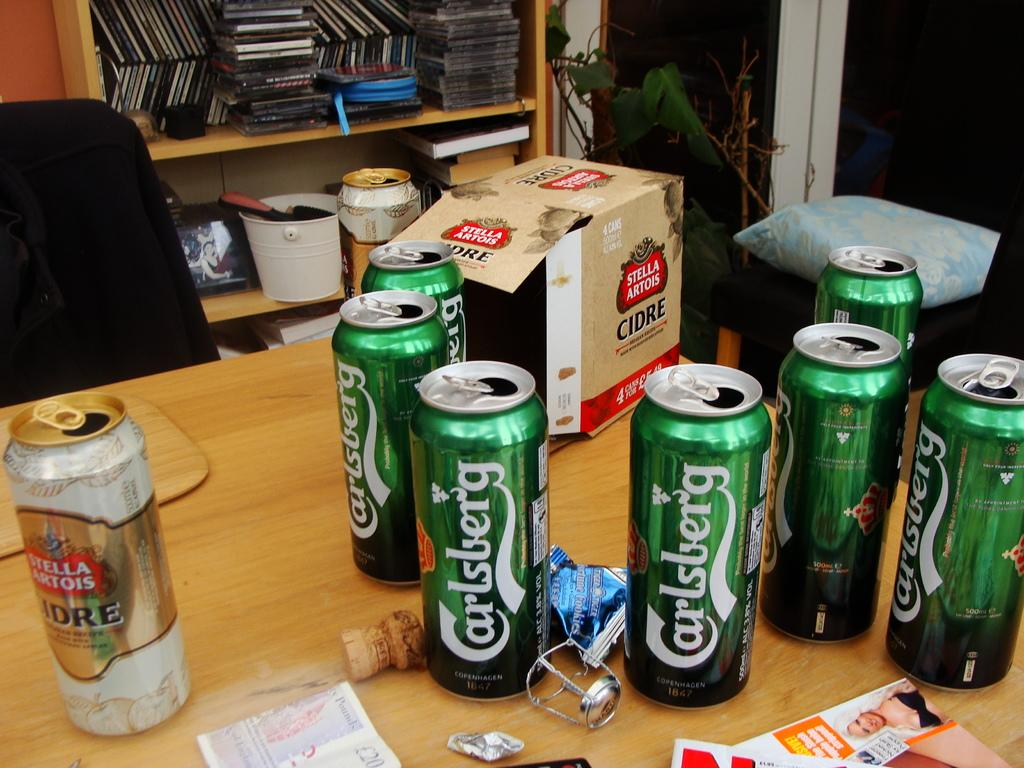<image>
Give a short and clear explanation of the subsequent image. Amongst a bunch of aluminum cans Carlsberg is printed in white on a few of them. 